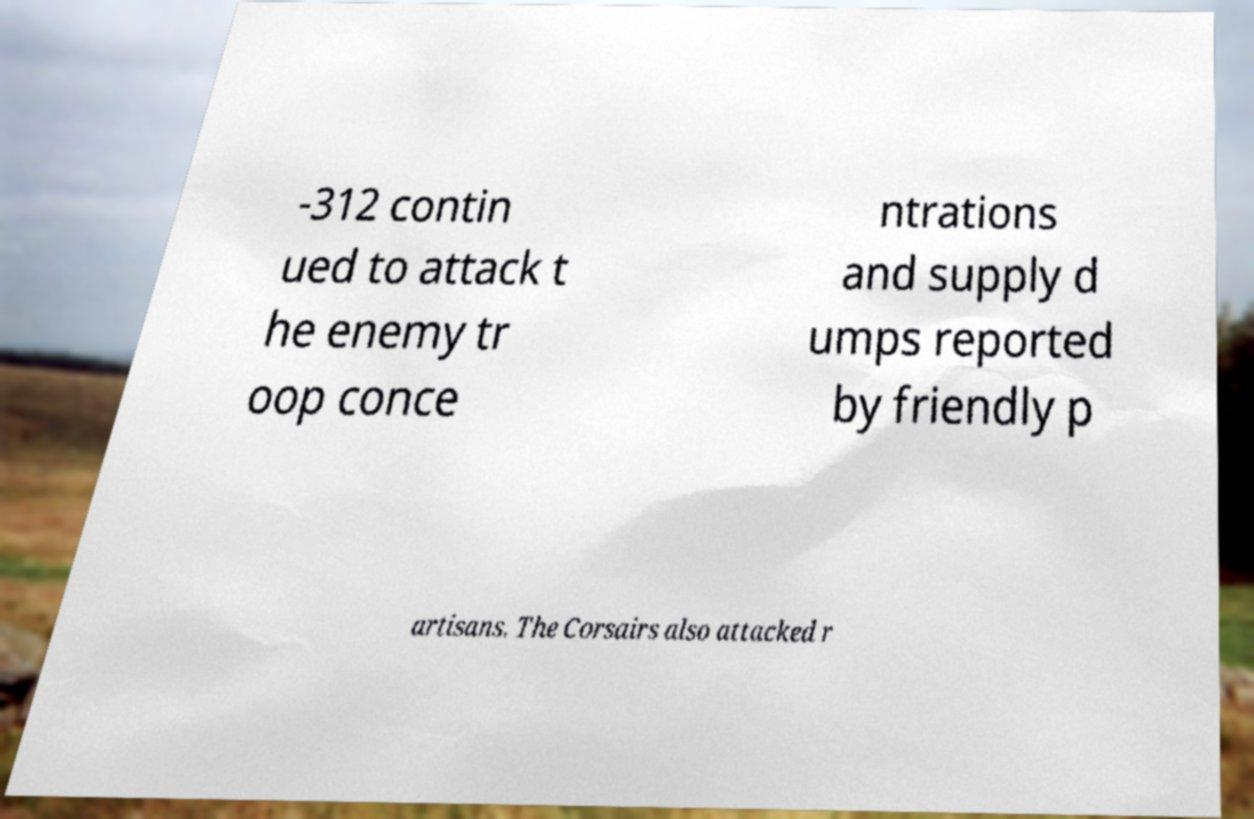For documentation purposes, I need the text within this image transcribed. Could you provide that? -312 contin ued to attack t he enemy tr oop conce ntrations and supply d umps reported by friendly p artisans. The Corsairs also attacked r 